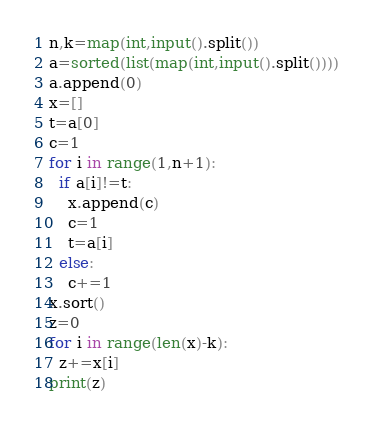<code> <loc_0><loc_0><loc_500><loc_500><_Python_>n,k=map(int,input().split())
a=sorted(list(map(int,input().split())))
a.append(0)
x=[]
t=a[0]
c=1
for i in range(1,n+1):
  if a[i]!=t:
    x.append(c)
    c=1
    t=a[i]
  else:
    c+=1
x.sort()
z=0
for i in range(len(x)-k):
  z+=x[i]
print(z)</code> 